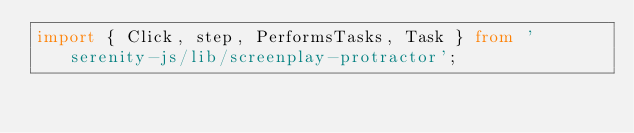Convert code to text. <code><loc_0><loc_0><loc_500><loc_500><_TypeScript_>import { Click, step, PerformsTasks, Task } from 'serenity-js/lib/screenplay-protractor';
</code> 